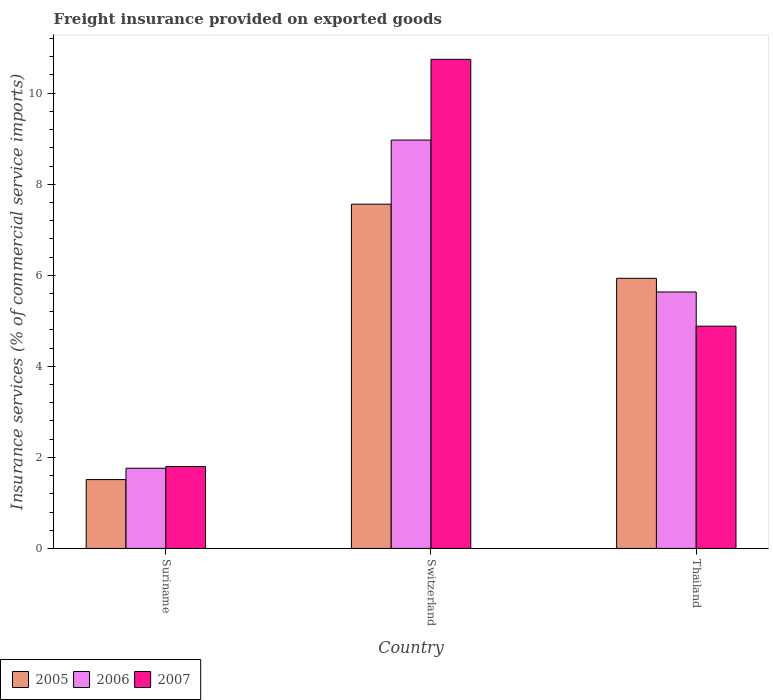How many different coloured bars are there?
Make the answer very short. 3. How many groups of bars are there?
Ensure brevity in your answer.  3. How many bars are there on the 2nd tick from the left?
Make the answer very short. 3. How many bars are there on the 2nd tick from the right?
Give a very brief answer. 3. What is the label of the 3rd group of bars from the left?
Your response must be concise. Thailand. What is the freight insurance provided on exported goods in 2005 in Thailand?
Your answer should be very brief. 5.93. Across all countries, what is the maximum freight insurance provided on exported goods in 2007?
Offer a very short reply. 10.74. Across all countries, what is the minimum freight insurance provided on exported goods in 2007?
Offer a very short reply. 1.8. In which country was the freight insurance provided on exported goods in 2006 maximum?
Provide a short and direct response. Switzerland. In which country was the freight insurance provided on exported goods in 2005 minimum?
Offer a terse response. Suriname. What is the total freight insurance provided on exported goods in 2005 in the graph?
Ensure brevity in your answer.  15.01. What is the difference between the freight insurance provided on exported goods in 2007 in Suriname and that in Thailand?
Make the answer very short. -3.08. What is the difference between the freight insurance provided on exported goods in 2005 in Suriname and the freight insurance provided on exported goods in 2006 in Thailand?
Provide a short and direct response. -4.12. What is the average freight insurance provided on exported goods in 2007 per country?
Offer a terse response. 5.81. What is the difference between the freight insurance provided on exported goods of/in 2007 and freight insurance provided on exported goods of/in 2005 in Thailand?
Keep it short and to the point. -1.05. In how many countries, is the freight insurance provided on exported goods in 2005 greater than 6.4 %?
Your response must be concise. 1. What is the ratio of the freight insurance provided on exported goods in 2007 in Switzerland to that in Thailand?
Provide a succinct answer. 2.2. Is the freight insurance provided on exported goods in 2007 in Suriname less than that in Switzerland?
Keep it short and to the point. Yes. Is the difference between the freight insurance provided on exported goods in 2007 in Switzerland and Thailand greater than the difference between the freight insurance provided on exported goods in 2005 in Switzerland and Thailand?
Offer a terse response. Yes. What is the difference between the highest and the second highest freight insurance provided on exported goods in 2007?
Make the answer very short. -8.94. What is the difference between the highest and the lowest freight insurance provided on exported goods in 2007?
Provide a short and direct response. 8.94. Is the sum of the freight insurance provided on exported goods in 2006 in Switzerland and Thailand greater than the maximum freight insurance provided on exported goods in 2005 across all countries?
Provide a short and direct response. Yes. What does the 2nd bar from the right in Switzerland represents?
Your answer should be compact. 2006. How many countries are there in the graph?
Ensure brevity in your answer.  3. What is the difference between two consecutive major ticks on the Y-axis?
Offer a terse response. 2. How are the legend labels stacked?
Ensure brevity in your answer.  Horizontal. What is the title of the graph?
Provide a succinct answer. Freight insurance provided on exported goods. Does "1971" appear as one of the legend labels in the graph?
Give a very brief answer. No. What is the label or title of the X-axis?
Your answer should be very brief. Country. What is the label or title of the Y-axis?
Your response must be concise. Insurance services (% of commercial service imports). What is the Insurance services (% of commercial service imports) of 2005 in Suriname?
Ensure brevity in your answer.  1.51. What is the Insurance services (% of commercial service imports) in 2006 in Suriname?
Make the answer very short. 1.76. What is the Insurance services (% of commercial service imports) in 2007 in Suriname?
Your answer should be compact. 1.8. What is the Insurance services (% of commercial service imports) in 2005 in Switzerland?
Provide a short and direct response. 7.56. What is the Insurance services (% of commercial service imports) in 2006 in Switzerland?
Make the answer very short. 8.97. What is the Insurance services (% of commercial service imports) in 2007 in Switzerland?
Make the answer very short. 10.74. What is the Insurance services (% of commercial service imports) in 2005 in Thailand?
Your response must be concise. 5.93. What is the Insurance services (% of commercial service imports) of 2006 in Thailand?
Make the answer very short. 5.63. What is the Insurance services (% of commercial service imports) in 2007 in Thailand?
Offer a very short reply. 4.88. Across all countries, what is the maximum Insurance services (% of commercial service imports) of 2005?
Keep it short and to the point. 7.56. Across all countries, what is the maximum Insurance services (% of commercial service imports) in 2006?
Make the answer very short. 8.97. Across all countries, what is the maximum Insurance services (% of commercial service imports) in 2007?
Make the answer very short. 10.74. Across all countries, what is the minimum Insurance services (% of commercial service imports) in 2005?
Make the answer very short. 1.51. Across all countries, what is the minimum Insurance services (% of commercial service imports) of 2006?
Offer a terse response. 1.76. Across all countries, what is the minimum Insurance services (% of commercial service imports) in 2007?
Give a very brief answer. 1.8. What is the total Insurance services (% of commercial service imports) in 2005 in the graph?
Provide a succinct answer. 15.01. What is the total Insurance services (% of commercial service imports) in 2006 in the graph?
Ensure brevity in your answer.  16.37. What is the total Insurance services (% of commercial service imports) of 2007 in the graph?
Your answer should be compact. 17.43. What is the difference between the Insurance services (% of commercial service imports) of 2005 in Suriname and that in Switzerland?
Your answer should be very brief. -6.05. What is the difference between the Insurance services (% of commercial service imports) in 2006 in Suriname and that in Switzerland?
Your response must be concise. -7.21. What is the difference between the Insurance services (% of commercial service imports) of 2007 in Suriname and that in Switzerland?
Make the answer very short. -8.94. What is the difference between the Insurance services (% of commercial service imports) of 2005 in Suriname and that in Thailand?
Give a very brief answer. -4.42. What is the difference between the Insurance services (% of commercial service imports) in 2006 in Suriname and that in Thailand?
Provide a succinct answer. -3.87. What is the difference between the Insurance services (% of commercial service imports) of 2007 in Suriname and that in Thailand?
Ensure brevity in your answer.  -3.08. What is the difference between the Insurance services (% of commercial service imports) of 2005 in Switzerland and that in Thailand?
Your answer should be very brief. 1.63. What is the difference between the Insurance services (% of commercial service imports) in 2006 in Switzerland and that in Thailand?
Your answer should be compact. 3.34. What is the difference between the Insurance services (% of commercial service imports) of 2007 in Switzerland and that in Thailand?
Keep it short and to the point. 5.86. What is the difference between the Insurance services (% of commercial service imports) in 2005 in Suriname and the Insurance services (% of commercial service imports) in 2006 in Switzerland?
Your answer should be compact. -7.46. What is the difference between the Insurance services (% of commercial service imports) of 2005 in Suriname and the Insurance services (% of commercial service imports) of 2007 in Switzerland?
Give a very brief answer. -9.23. What is the difference between the Insurance services (% of commercial service imports) of 2006 in Suriname and the Insurance services (% of commercial service imports) of 2007 in Switzerland?
Your answer should be very brief. -8.98. What is the difference between the Insurance services (% of commercial service imports) of 2005 in Suriname and the Insurance services (% of commercial service imports) of 2006 in Thailand?
Your response must be concise. -4.12. What is the difference between the Insurance services (% of commercial service imports) of 2005 in Suriname and the Insurance services (% of commercial service imports) of 2007 in Thailand?
Your answer should be very brief. -3.37. What is the difference between the Insurance services (% of commercial service imports) in 2006 in Suriname and the Insurance services (% of commercial service imports) in 2007 in Thailand?
Give a very brief answer. -3.12. What is the difference between the Insurance services (% of commercial service imports) of 2005 in Switzerland and the Insurance services (% of commercial service imports) of 2006 in Thailand?
Provide a short and direct response. 1.93. What is the difference between the Insurance services (% of commercial service imports) in 2005 in Switzerland and the Insurance services (% of commercial service imports) in 2007 in Thailand?
Make the answer very short. 2.68. What is the difference between the Insurance services (% of commercial service imports) in 2006 in Switzerland and the Insurance services (% of commercial service imports) in 2007 in Thailand?
Your answer should be compact. 4.09. What is the average Insurance services (% of commercial service imports) in 2005 per country?
Your answer should be very brief. 5. What is the average Insurance services (% of commercial service imports) of 2006 per country?
Provide a short and direct response. 5.46. What is the average Insurance services (% of commercial service imports) in 2007 per country?
Offer a terse response. 5.81. What is the difference between the Insurance services (% of commercial service imports) in 2005 and Insurance services (% of commercial service imports) in 2006 in Suriname?
Offer a terse response. -0.25. What is the difference between the Insurance services (% of commercial service imports) of 2005 and Insurance services (% of commercial service imports) of 2007 in Suriname?
Provide a succinct answer. -0.29. What is the difference between the Insurance services (% of commercial service imports) in 2006 and Insurance services (% of commercial service imports) in 2007 in Suriname?
Make the answer very short. -0.04. What is the difference between the Insurance services (% of commercial service imports) of 2005 and Insurance services (% of commercial service imports) of 2006 in Switzerland?
Your answer should be compact. -1.41. What is the difference between the Insurance services (% of commercial service imports) of 2005 and Insurance services (% of commercial service imports) of 2007 in Switzerland?
Provide a short and direct response. -3.18. What is the difference between the Insurance services (% of commercial service imports) of 2006 and Insurance services (% of commercial service imports) of 2007 in Switzerland?
Your answer should be compact. -1.77. What is the difference between the Insurance services (% of commercial service imports) of 2005 and Insurance services (% of commercial service imports) of 2006 in Thailand?
Your answer should be compact. 0.3. What is the difference between the Insurance services (% of commercial service imports) of 2005 and Insurance services (% of commercial service imports) of 2007 in Thailand?
Your answer should be very brief. 1.05. What is the difference between the Insurance services (% of commercial service imports) in 2006 and Insurance services (% of commercial service imports) in 2007 in Thailand?
Your response must be concise. 0.75. What is the ratio of the Insurance services (% of commercial service imports) in 2005 in Suriname to that in Switzerland?
Your response must be concise. 0.2. What is the ratio of the Insurance services (% of commercial service imports) of 2006 in Suriname to that in Switzerland?
Make the answer very short. 0.2. What is the ratio of the Insurance services (% of commercial service imports) of 2007 in Suriname to that in Switzerland?
Offer a very short reply. 0.17. What is the ratio of the Insurance services (% of commercial service imports) of 2005 in Suriname to that in Thailand?
Give a very brief answer. 0.25. What is the ratio of the Insurance services (% of commercial service imports) in 2006 in Suriname to that in Thailand?
Ensure brevity in your answer.  0.31. What is the ratio of the Insurance services (% of commercial service imports) of 2007 in Suriname to that in Thailand?
Your answer should be compact. 0.37. What is the ratio of the Insurance services (% of commercial service imports) in 2005 in Switzerland to that in Thailand?
Give a very brief answer. 1.27. What is the ratio of the Insurance services (% of commercial service imports) in 2006 in Switzerland to that in Thailand?
Your response must be concise. 1.59. What is the ratio of the Insurance services (% of commercial service imports) of 2007 in Switzerland to that in Thailand?
Ensure brevity in your answer.  2.2. What is the difference between the highest and the second highest Insurance services (% of commercial service imports) in 2005?
Give a very brief answer. 1.63. What is the difference between the highest and the second highest Insurance services (% of commercial service imports) in 2006?
Offer a very short reply. 3.34. What is the difference between the highest and the second highest Insurance services (% of commercial service imports) in 2007?
Your response must be concise. 5.86. What is the difference between the highest and the lowest Insurance services (% of commercial service imports) of 2005?
Provide a succinct answer. 6.05. What is the difference between the highest and the lowest Insurance services (% of commercial service imports) in 2006?
Provide a short and direct response. 7.21. What is the difference between the highest and the lowest Insurance services (% of commercial service imports) in 2007?
Offer a terse response. 8.94. 